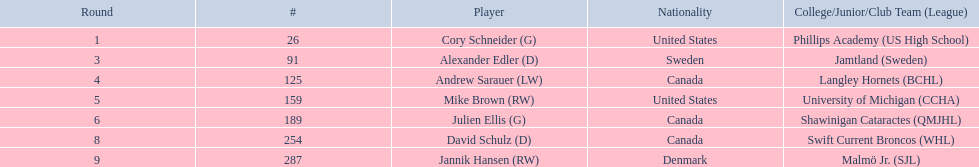Which colleges and junior leagues did the players go to? Phillips Academy (US High School), Jamtland (Sweden), Langley Hornets (BCHL), University of Michigan (CCHA), Shawinigan Cataractes (QMJHL), Swift Current Broncos (WHL), Malmö Jr. (SJL). Furthermore, who among them played for the langley hornets? Andrew Sarauer (LW). 